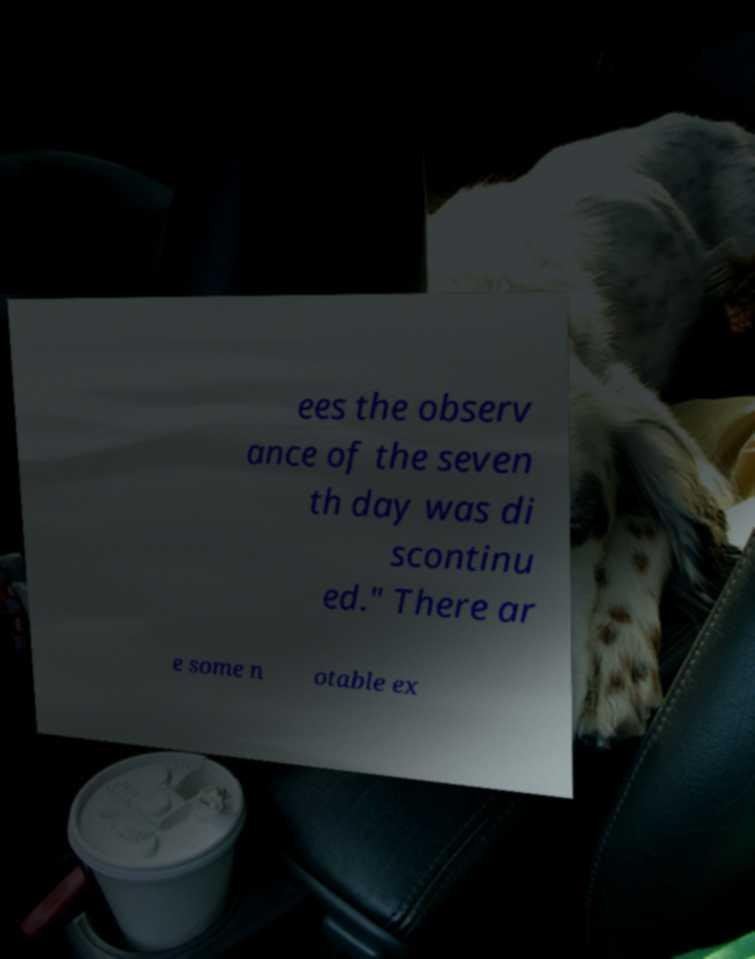Can you read and provide the text displayed in the image?This photo seems to have some interesting text. Can you extract and type it out for me? ees the observ ance of the seven th day was di scontinu ed." There ar e some n otable ex 